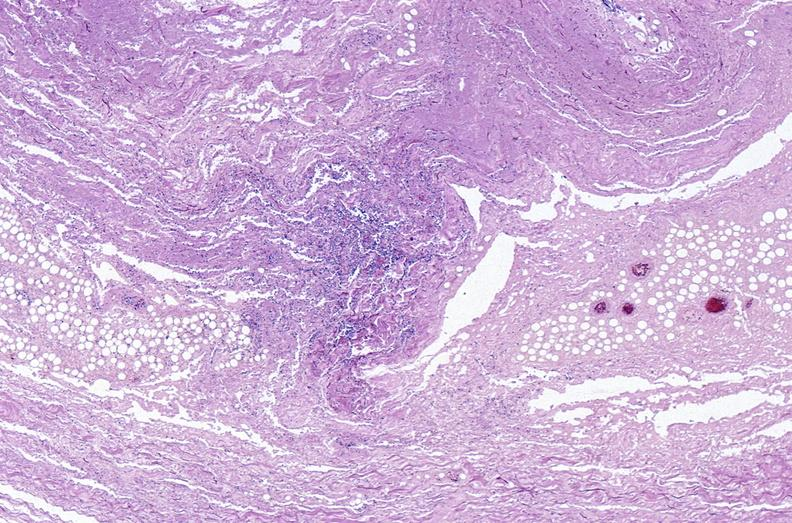what does this image show?
Answer the question using a single word or phrase. Panniculitis and fascitis 